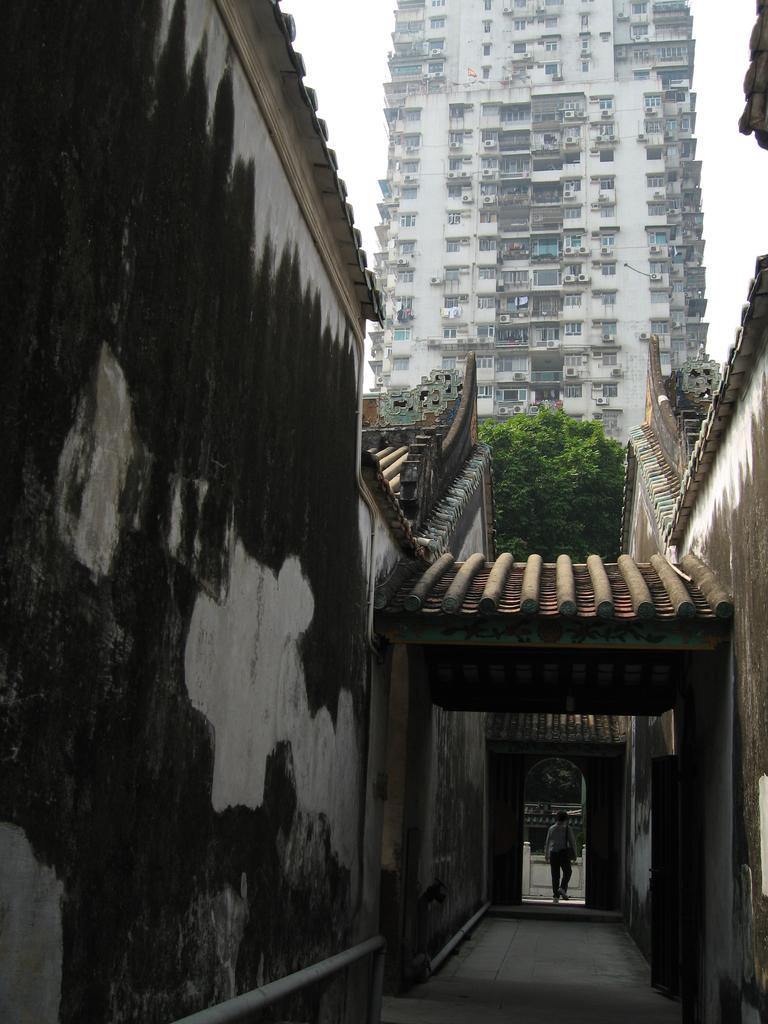What type of structures can be seen in the image? There are buildings in the image. What feature of the buildings is visible in the image? There are windows visible in the image. What type of vegetation is present in the image? There are trees in the image. What is visible in the background of the image? The sky is visible in the image. What is the person in the image doing? There is a person walking in the image. Can you tell me how many clovers are growing near the person walking in the image? There is no mention of clovers in the image, so it is not possible to determine how many are present. What type of door can be seen in the image? There is no door visible in the image; it only features buildings, windows, trees, the sky, and a person walking. 